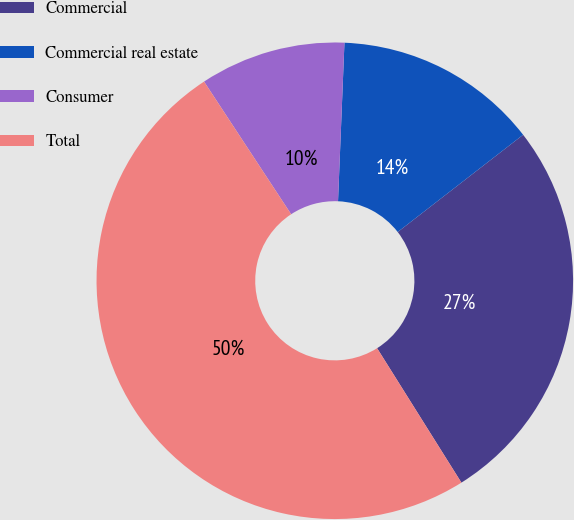Convert chart to OTSL. <chart><loc_0><loc_0><loc_500><loc_500><pie_chart><fcel>Commercial<fcel>Commercial real estate<fcel>Consumer<fcel>Total<nl><fcel>26.58%<fcel>13.86%<fcel>9.89%<fcel>49.67%<nl></chart> 